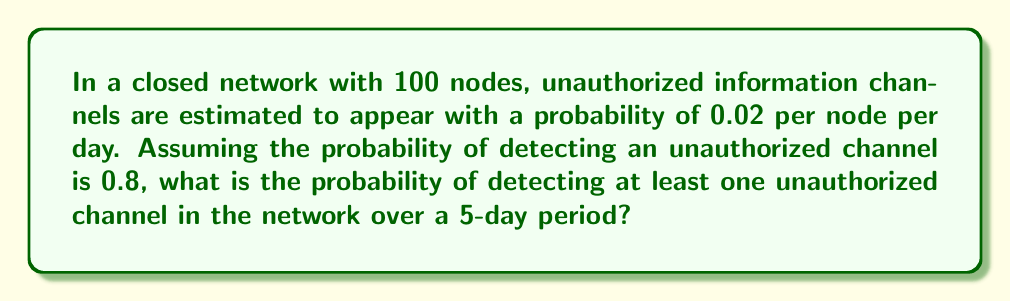Solve this math problem. Let's approach this step-by-step:

1) First, let's calculate the probability of an unauthorized channel appearing on any given node in 5 days:
   $P(\text{channel in 5 days}) = 1 - (1 - 0.02)^5 = 1 - 0.9025 = 0.0975$

2) Now, the probability of detecting a channel if it exists is 0.8. So the probability of detecting a channel on a single node in 5 days is:
   $P(\text{detect on one node}) = 0.0975 * 0.8 = 0.078$

3) The probability of not detecting a channel on a single node is:
   $P(\text{not detect on one node}) = 1 - 0.078 = 0.922$

4) For the entire network of 100 nodes, the probability of not detecting any channel is:
   $P(\text{not detect on any node}) = 0.922^{100}$

5) Therefore, the probability of detecting at least one channel is:
   $P(\text{detect at least one}) = 1 - 0.922^{100}$

6) Calculating this:
   $P(\text{detect at least one}) = 1 - 0.922^{100} = 1 - 0.000314 = 0.999686$
Answer: 0.999686 